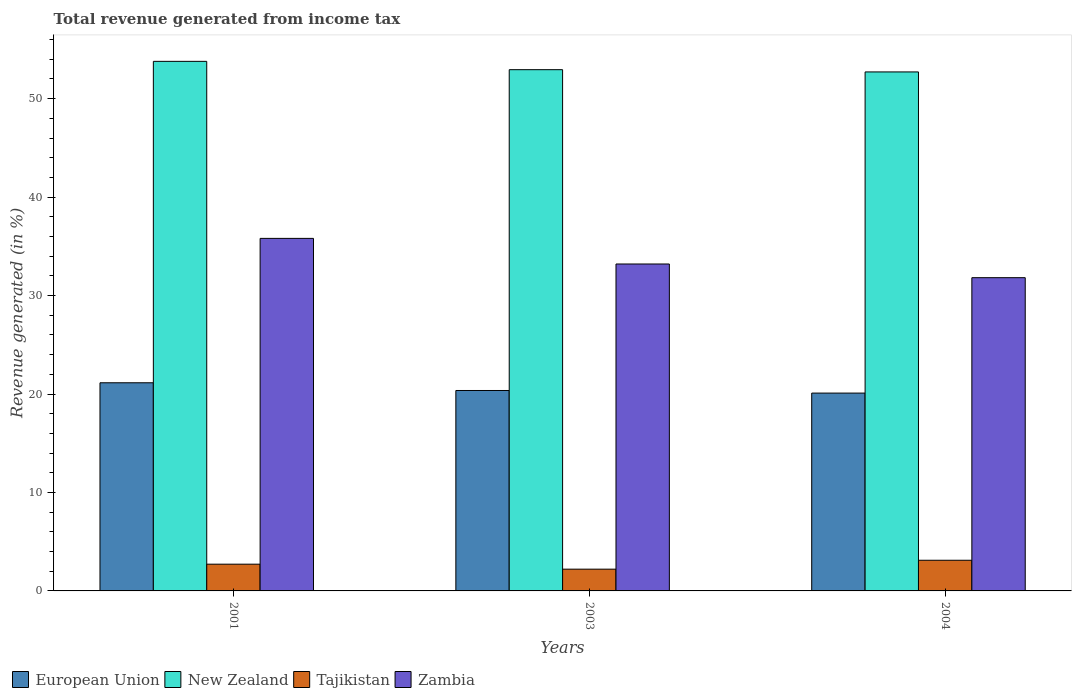How many different coloured bars are there?
Offer a terse response. 4. How many groups of bars are there?
Give a very brief answer. 3. How many bars are there on the 2nd tick from the right?
Give a very brief answer. 4. What is the label of the 1st group of bars from the left?
Provide a short and direct response. 2001. What is the total revenue generated in European Union in 2001?
Your response must be concise. 21.14. Across all years, what is the maximum total revenue generated in Tajikistan?
Provide a succinct answer. 3.11. Across all years, what is the minimum total revenue generated in Tajikistan?
Offer a terse response. 2.21. In which year was the total revenue generated in Tajikistan maximum?
Provide a short and direct response. 2004. What is the total total revenue generated in European Union in the graph?
Your answer should be compact. 61.6. What is the difference between the total revenue generated in European Union in 2001 and that in 2003?
Offer a very short reply. 0.78. What is the difference between the total revenue generated in Tajikistan in 2001 and the total revenue generated in New Zealand in 2004?
Provide a short and direct response. -50. What is the average total revenue generated in Tajikistan per year?
Give a very brief answer. 2.68. In the year 2004, what is the difference between the total revenue generated in New Zealand and total revenue generated in Zambia?
Your response must be concise. 20.9. In how many years, is the total revenue generated in Zambia greater than 4 %?
Your response must be concise. 3. What is the ratio of the total revenue generated in European Union in 2001 to that in 2004?
Your answer should be very brief. 1.05. What is the difference between the highest and the second highest total revenue generated in Zambia?
Provide a succinct answer. 2.6. What is the difference between the highest and the lowest total revenue generated in Zambia?
Ensure brevity in your answer.  3.99. In how many years, is the total revenue generated in Zambia greater than the average total revenue generated in Zambia taken over all years?
Your response must be concise. 1. Is the sum of the total revenue generated in Zambia in 2001 and 2004 greater than the maximum total revenue generated in Tajikistan across all years?
Your response must be concise. Yes. What does the 2nd bar from the left in 2004 represents?
Make the answer very short. New Zealand. What does the 2nd bar from the right in 2001 represents?
Your answer should be compact. Tajikistan. Does the graph contain any zero values?
Make the answer very short. No. Does the graph contain grids?
Your answer should be very brief. No. How are the legend labels stacked?
Your answer should be compact. Horizontal. What is the title of the graph?
Your response must be concise. Total revenue generated from income tax. Does "Malaysia" appear as one of the legend labels in the graph?
Offer a very short reply. No. What is the label or title of the Y-axis?
Offer a terse response. Revenue generated (in %). What is the Revenue generated (in %) in European Union in 2001?
Make the answer very short. 21.14. What is the Revenue generated (in %) of New Zealand in 2001?
Make the answer very short. 53.79. What is the Revenue generated (in %) of Tajikistan in 2001?
Offer a very short reply. 2.72. What is the Revenue generated (in %) in Zambia in 2001?
Provide a short and direct response. 35.81. What is the Revenue generated (in %) of European Union in 2003?
Give a very brief answer. 20.36. What is the Revenue generated (in %) of New Zealand in 2003?
Provide a succinct answer. 52.94. What is the Revenue generated (in %) of Tajikistan in 2003?
Ensure brevity in your answer.  2.21. What is the Revenue generated (in %) of Zambia in 2003?
Your answer should be compact. 33.21. What is the Revenue generated (in %) in European Union in 2004?
Keep it short and to the point. 20.09. What is the Revenue generated (in %) of New Zealand in 2004?
Offer a very short reply. 52.71. What is the Revenue generated (in %) of Tajikistan in 2004?
Offer a terse response. 3.11. What is the Revenue generated (in %) in Zambia in 2004?
Give a very brief answer. 31.82. Across all years, what is the maximum Revenue generated (in %) of European Union?
Keep it short and to the point. 21.14. Across all years, what is the maximum Revenue generated (in %) in New Zealand?
Provide a short and direct response. 53.79. Across all years, what is the maximum Revenue generated (in %) of Tajikistan?
Make the answer very short. 3.11. Across all years, what is the maximum Revenue generated (in %) in Zambia?
Provide a succinct answer. 35.81. Across all years, what is the minimum Revenue generated (in %) of European Union?
Give a very brief answer. 20.09. Across all years, what is the minimum Revenue generated (in %) in New Zealand?
Your answer should be very brief. 52.71. Across all years, what is the minimum Revenue generated (in %) of Tajikistan?
Make the answer very short. 2.21. Across all years, what is the minimum Revenue generated (in %) in Zambia?
Give a very brief answer. 31.82. What is the total Revenue generated (in %) of European Union in the graph?
Give a very brief answer. 61.6. What is the total Revenue generated (in %) in New Zealand in the graph?
Provide a short and direct response. 159.45. What is the total Revenue generated (in %) in Tajikistan in the graph?
Offer a very short reply. 8.04. What is the total Revenue generated (in %) in Zambia in the graph?
Your answer should be very brief. 100.83. What is the difference between the Revenue generated (in %) of European Union in 2001 and that in 2003?
Your response must be concise. 0.78. What is the difference between the Revenue generated (in %) in New Zealand in 2001 and that in 2003?
Your answer should be compact. 0.85. What is the difference between the Revenue generated (in %) of Tajikistan in 2001 and that in 2003?
Your answer should be compact. 0.51. What is the difference between the Revenue generated (in %) of Zambia in 2001 and that in 2003?
Ensure brevity in your answer.  2.6. What is the difference between the Revenue generated (in %) of European Union in 2001 and that in 2004?
Offer a terse response. 1.05. What is the difference between the Revenue generated (in %) of New Zealand in 2001 and that in 2004?
Offer a terse response. 1.07. What is the difference between the Revenue generated (in %) of Tajikistan in 2001 and that in 2004?
Your response must be concise. -0.4. What is the difference between the Revenue generated (in %) of Zambia in 2001 and that in 2004?
Your answer should be compact. 3.99. What is the difference between the Revenue generated (in %) in European Union in 2003 and that in 2004?
Your response must be concise. 0.26. What is the difference between the Revenue generated (in %) of New Zealand in 2003 and that in 2004?
Give a very brief answer. 0.23. What is the difference between the Revenue generated (in %) in Tajikistan in 2003 and that in 2004?
Provide a short and direct response. -0.9. What is the difference between the Revenue generated (in %) in Zambia in 2003 and that in 2004?
Ensure brevity in your answer.  1.39. What is the difference between the Revenue generated (in %) in European Union in 2001 and the Revenue generated (in %) in New Zealand in 2003?
Your answer should be compact. -31.8. What is the difference between the Revenue generated (in %) of European Union in 2001 and the Revenue generated (in %) of Tajikistan in 2003?
Keep it short and to the point. 18.93. What is the difference between the Revenue generated (in %) of European Union in 2001 and the Revenue generated (in %) of Zambia in 2003?
Your answer should be compact. -12.06. What is the difference between the Revenue generated (in %) of New Zealand in 2001 and the Revenue generated (in %) of Tajikistan in 2003?
Make the answer very short. 51.58. What is the difference between the Revenue generated (in %) in New Zealand in 2001 and the Revenue generated (in %) in Zambia in 2003?
Your answer should be very brief. 20.58. What is the difference between the Revenue generated (in %) in Tajikistan in 2001 and the Revenue generated (in %) in Zambia in 2003?
Provide a succinct answer. -30.49. What is the difference between the Revenue generated (in %) in European Union in 2001 and the Revenue generated (in %) in New Zealand in 2004?
Offer a terse response. -31.57. What is the difference between the Revenue generated (in %) in European Union in 2001 and the Revenue generated (in %) in Tajikistan in 2004?
Give a very brief answer. 18.03. What is the difference between the Revenue generated (in %) in European Union in 2001 and the Revenue generated (in %) in Zambia in 2004?
Give a very brief answer. -10.67. What is the difference between the Revenue generated (in %) of New Zealand in 2001 and the Revenue generated (in %) of Tajikistan in 2004?
Offer a terse response. 50.67. What is the difference between the Revenue generated (in %) of New Zealand in 2001 and the Revenue generated (in %) of Zambia in 2004?
Keep it short and to the point. 21.97. What is the difference between the Revenue generated (in %) in Tajikistan in 2001 and the Revenue generated (in %) in Zambia in 2004?
Make the answer very short. -29.1. What is the difference between the Revenue generated (in %) of European Union in 2003 and the Revenue generated (in %) of New Zealand in 2004?
Offer a very short reply. -32.36. What is the difference between the Revenue generated (in %) in European Union in 2003 and the Revenue generated (in %) in Tajikistan in 2004?
Offer a very short reply. 17.24. What is the difference between the Revenue generated (in %) in European Union in 2003 and the Revenue generated (in %) in Zambia in 2004?
Offer a terse response. -11.46. What is the difference between the Revenue generated (in %) of New Zealand in 2003 and the Revenue generated (in %) of Tajikistan in 2004?
Give a very brief answer. 49.83. What is the difference between the Revenue generated (in %) in New Zealand in 2003 and the Revenue generated (in %) in Zambia in 2004?
Keep it short and to the point. 21.13. What is the difference between the Revenue generated (in %) of Tajikistan in 2003 and the Revenue generated (in %) of Zambia in 2004?
Your answer should be compact. -29.61. What is the average Revenue generated (in %) in European Union per year?
Provide a short and direct response. 20.53. What is the average Revenue generated (in %) in New Zealand per year?
Your response must be concise. 53.15. What is the average Revenue generated (in %) of Tajikistan per year?
Your answer should be compact. 2.68. What is the average Revenue generated (in %) in Zambia per year?
Ensure brevity in your answer.  33.61. In the year 2001, what is the difference between the Revenue generated (in %) in European Union and Revenue generated (in %) in New Zealand?
Ensure brevity in your answer.  -32.65. In the year 2001, what is the difference between the Revenue generated (in %) of European Union and Revenue generated (in %) of Tajikistan?
Keep it short and to the point. 18.43. In the year 2001, what is the difference between the Revenue generated (in %) of European Union and Revenue generated (in %) of Zambia?
Offer a very short reply. -14.67. In the year 2001, what is the difference between the Revenue generated (in %) in New Zealand and Revenue generated (in %) in Tajikistan?
Your answer should be very brief. 51.07. In the year 2001, what is the difference between the Revenue generated (in %) in New Zealand and Revenue generated (in %) in Zambia?
Provide a short and direct response. 17.98. In the year 2001, what is the difference between the Revenue generated (in %) in Tajikistan and Revenue generated (in %) in Zambia?
Make the answer very short. -33.09. In the year 2003, what is the difference between the Revenue generated (in %) of European Union and Revenue generated (in %) of New Zealand?
Offer a terse response. -32.58. In the year 2003, what is the difference between the Revenue generated (in %) of European Union and Revenue generated (in %) of Tajikistan?
Give a very brief answer. 18.15. In the year 2003, what is the difference between the Revenue generated (in %) in European Union and Revenue generated (in %) in Zambia?
Offer a terse response. -12.85. In the year 2003, what is the difference between the Revenue generated (in %) in New Zealand and Revenue generated (in %) in Tajikistan?
Provide a succinct answer. 50.73. In the year 2003, what is the difference between the Revenue generated (in %) of New Zealand and Revenue generated (in %) of Zambia?
Keep it short and to the point. 19.74. In the year 2003, what is the difference between the Revenue generated (in %) of Tajikistan and Revenue generated (in %) of Zambia?
Offer a terse response. -31. In the year 2004, what is the difference between the Revenue generated (in %) of European Union and Revenue generated (in %) of New Zealand?
Your answer should be compact. -32.62. In the year 2004, what is the difference between the Revenue generated (in %) of European Union and Revenue generated (in %) of Tajikistan?
Give a very brief answer. 16.98. In the year 2004, what is the difference between the Revenue generated (in %) in European Union and Revenue generated (in %) in Zambia?
Your answer should be compact. -11.72. In the year 2004, what is the difference between the Revenue generated (in %) in New Zealand and Revenue generated (in %) in Tajikistan?
Your answer should be very brief. 49.6. In the year 2004, what is the difference between the Revenue generated (in %) in New Zealand and Revenue generated (in %) in Zambia?
Offer a very short reply. 20.9. In the year 2004, what is the difference between the Revenue generated (in %) of Tajikistan and Revenue generated (in %) of Zambia?
Make the answer very short. -28.7. What is the ratio of the Revenue generated (in %) in New Zealand in 2001 to that in 2003?
Provide a short and direct response. 1.02. What is the ratio of the Revenue generated (in %) in Tajikistan in 2001 to that in 2003?
Give a very brief answer. 1.23. What is the ratio of the Revenue generated (in %) in Zambia in 2001 to that in 2003?
Make the answer very short. 1.08. What is the ratio of the Revenue generated (in %) of European Union in 2001 to that in 2004?
Ensure brevity in your answer.  1.05. What is the ratio of the Revenue generated (in %) in New Zealand in 2001 to that in 2004?
Offer a terse response. 1.02. What is the ratio of the Revenue generated (in %) of Tajikistan in 2001 to that in 2004?
Offer a very short reply. 0.87. What is the ratio of the Revenue generated (in %) of Zambia in 2001 to that in 2004?
Give a very brief answer. 1.13. What is the ratio of the Revenue generated (in %) in European Union in 2003 to that in 2004?
Provide a succinct answer. 1.01. What is the ratio of the Revenue generated (in %) in New Zealand in 2003 to that in 2004?
Ensure brevity in your answer.  1. What is the ratio of the Revenue generated (in %) in Tajikistan in 2003 to that in 2004?
Give a very brief answer. 0.71. What is the ratio of the Revenue generated (in %) of Zambia in 2003 to that in 2004?
Provide a succinct answer. 1.04. What is the difference between the highest and the second highest Revenue generated (in %) of European Union?
Ensure brevity in your answer.  0.78. What is the difference between the highest and the second highest Revenue generated (in %) of New Zealand?
Ensure brevity in your answer.  0.85. What is the difference between the highest and the second highest Revenue generated (in %) in Tajikistan?
Your answer should be compact. 0.4. What is the difference between the highest and the second highest Revenue generated (in %) in Zambia?
Make the answer very short. 2.6. What is the difference between the highest and the lowest Revenue generated (in %) in European Union?
Keep it short and to the point. 1.05. What is the difference between the highest and the lowest Revenue generated (in %) of New Zealand?
Keep it short and to the point. 1.07. What is the difference between the highest and the lowest Revenue generated (in %) in Tajikistan?
Your response must be concise. 0.9. What is the difference between the highest and the lowest Revenue generated (in %) in Zambia?
Offer a very short reply. 3.99. 